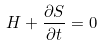Convert formula to latex. <formula><loc_0><loc_0><loc_500><loc_500>H + \frac { \partial S } { \partial t } = 0</formula> 